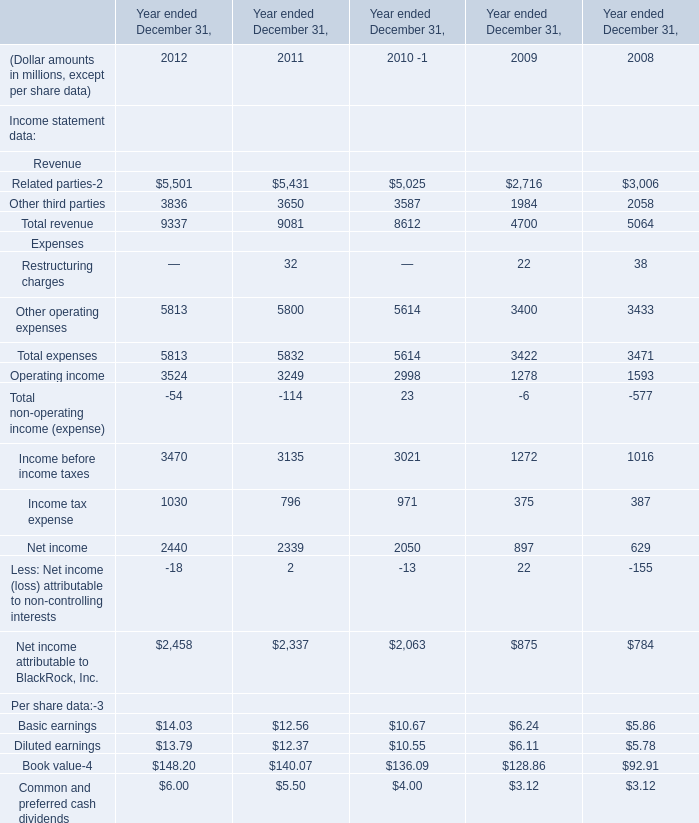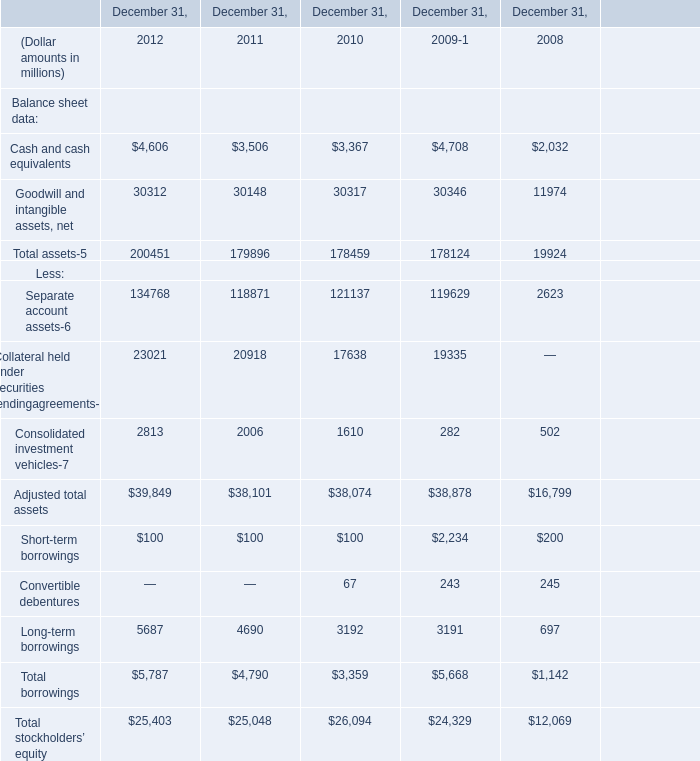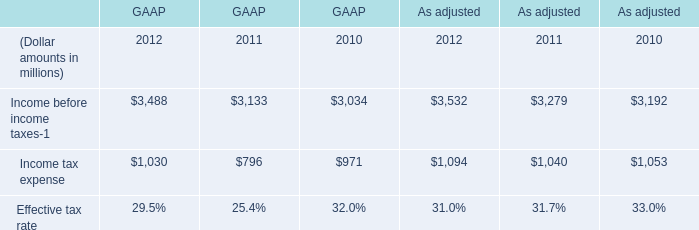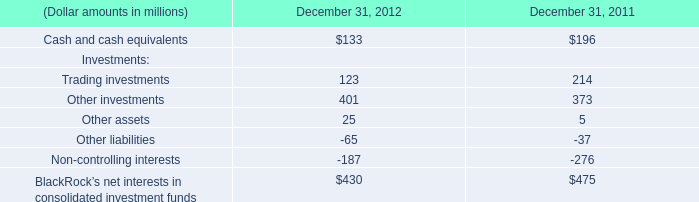What's the average of Total revenue in 2010,2011 and 2012? (in million) 
Computations: (((9337 + 9081) + 8612) / 3)
Answer: 9010.0. 